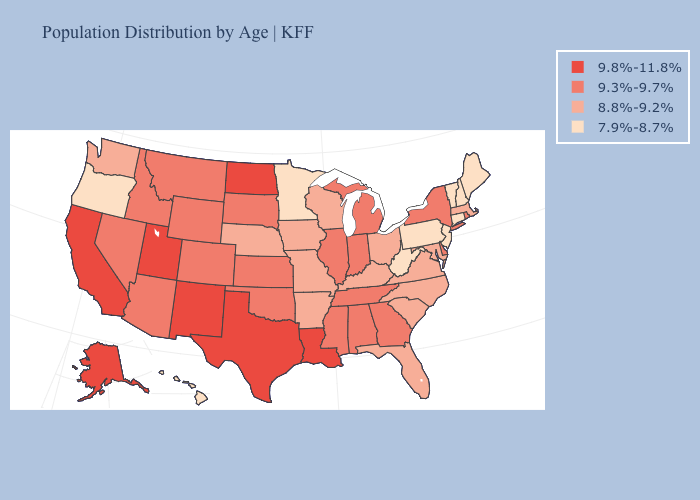Which states have the lowest value in the West?
Be succinct. Hawaii, Oregon. Does Nevada have a lower value than Mississippi?
Short answer required. No. What is the value of Oregon?
Short answer required. 7.9%-8.7%. What is the value of South Carolina?
Short answer required. 8.8%-9.2%. Does South Carolina have the highest value in the USA?
Quick response, please. No. Does Maryland have a lower value than Arkansas?
Answer briefly. No. What is the value of Massachusetts?
Write a very short answer. 8.8%-9.2%. What is the value of Kansas?
Keep it brief. 9.3%-9.7%. Does New Jersey have the lowest value in the USA?
Short answer required. Yes. Which states hav the highest value in the West?
Be succinct. Alaska, California, New Mexico, Utah. Does Minnesota have the lowest value in the MidWest?
Write a very short answer. Yes. Does Maryland have a lower value than Colorado?
Concise answer only. Yes. Does the first symbol in the legend represent the smallest category?
Give a very brief answer. No. 